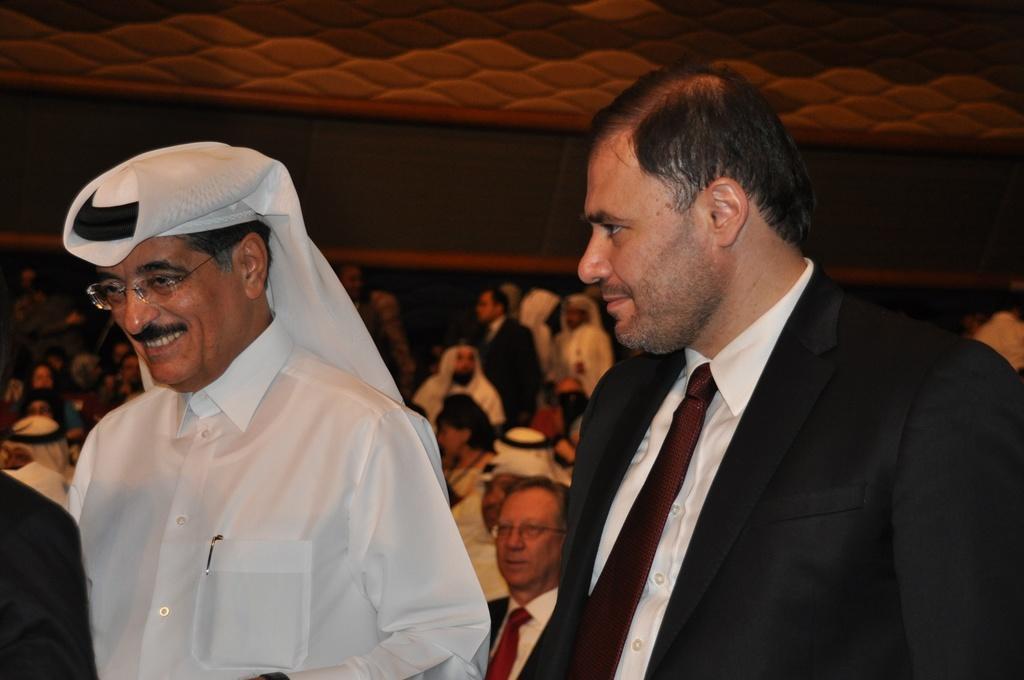Please provide a concise description of this image. In the image there are two men in a foreground and behind them there are many other people, it looks like there is some event being conducted. 